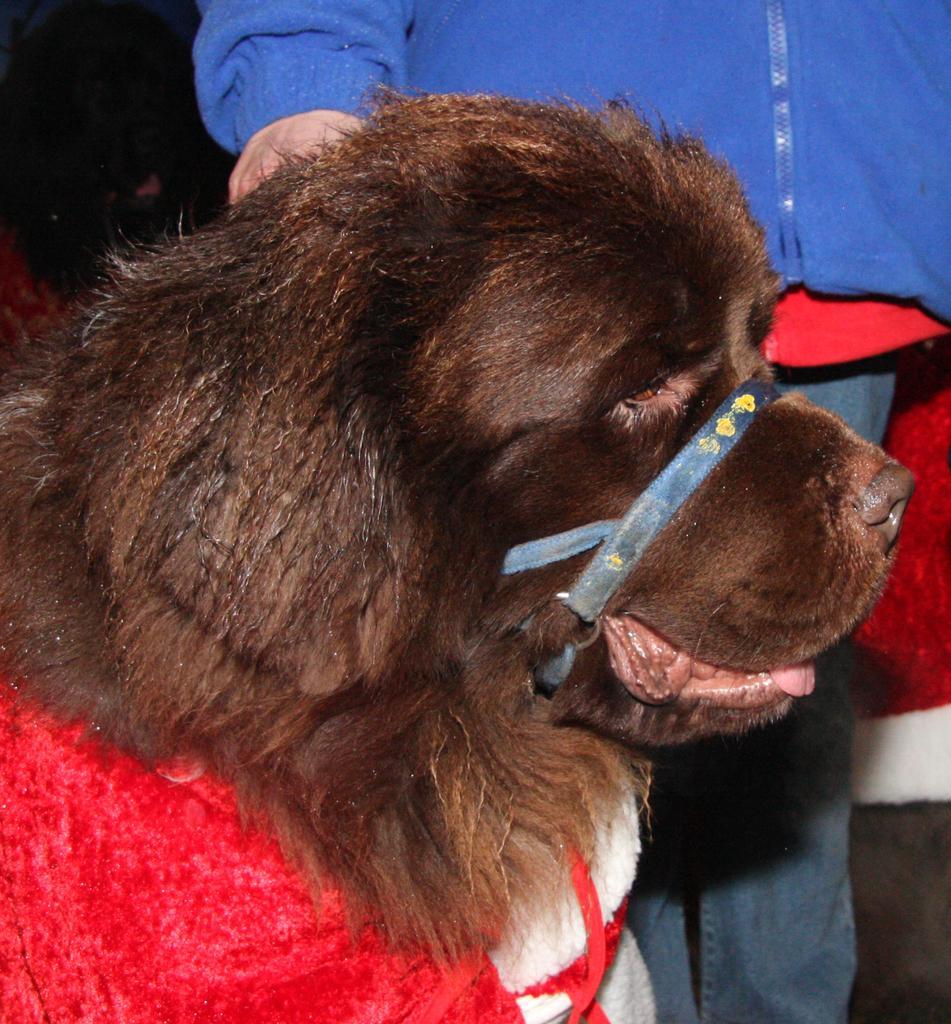How would you summarize this image in a sentence or two? In this picture we can see a dog and there is a person standing. In the background of the image it is dark. 